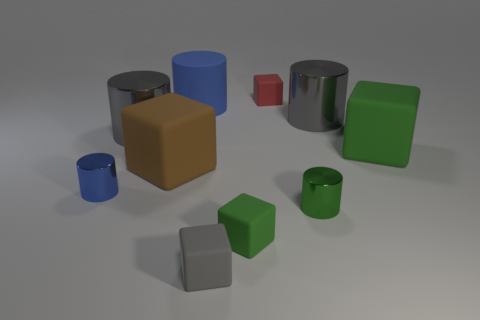Can you tell which objects might be heavier based on their size and material? While it's not possible to determine the exact weight without more information, typically in such a collection, objects that are larger and appear to be made of metal, like the grey shiny cylinder and larger tan cube, would likely be heavier. On the other hand, the smaller objects, particularly those that may be made of plastic or rubber due to their matte finishes and colors, like the small red and green cubes, are presumably lighter. 